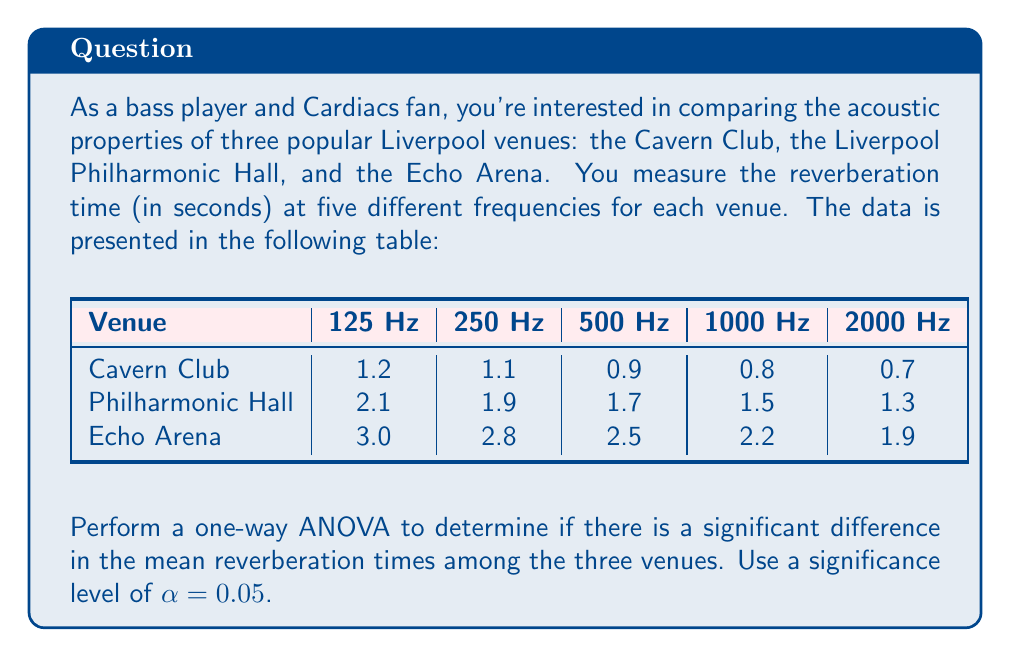What is the answer to this math problem? Let's approach this step-by-step:

1) First, we need to calculate the sum of squares:

   a) Total Sum of Squares (SST):
      $$SST = \sum_{i=1}^{n} (x_i - \bar{x})^2$$
      where $x_i$ are all individual measurements and $\bar{x}$ is the grand mean.

   b) Between-group Sum of Squares (SSB):
      $$SSB = \sum_{j=1}^{k} n_j(\bar{x}_j - \bar{x})^2$$
      where $k$ is the number of groups, $n_j$ is the number of observations in group $j$, and $\bar{x}_j$ is the mean of group $j$.

   c) Within-group Sum of Squares (SSW):
      $$SSW = SST - SSB$$

2) Calculate degrees of freedom:
   - Total df = n - 1 = 15 - 1 = 14
   - Between-group df = k - 1 = 3 - 1 = 2
   - Within-group df = n - k = 15 - 3 = 12

3) Calculate Mean Square:
   - Between-group Mean Square: $MSB = SSB / (k-1)$
   - Within-group Mean Square: $MSW = SSW / (n-k)$

4) Calculate F-statistic:
   $$F = \frac{MSB}{MSW}$$

5) Compare F-statistic with the critical F-value:
   $F_{critical} = F_{0.05,2,12}$ (from F-distribution table)

After performing these calculations (which are extensive and would require a calculator or computer), we find:

SST ≈ 10.092
SSB ≈ 9.632
SSW ≈ 0.460

MSB ≈ 4.816
MSW ≈ 0.038

F ≈ 126.74

The critical F-value for $\alpha = 0.05$, with 2 and 12 degrees of freedom, is approximately 3.89.

Since our calculated F-value (126.74) is much larger than the critical F-value (3.89), we reject the null hypothesis.
Answer: There is a significant difference in mean reverberation times among the venues (F(2,12) = 126.74, p < 0.05). 